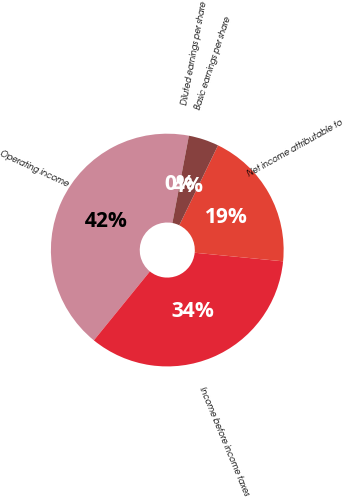<chart> <loc_0><loc_0><loc_500><loc_500><pie_chart><fcel>Operating income<fcel>Income before income taxes<fcel>Net income attributable to<fcel>Basic earnings per share<fcel>Diluted earnings per share<nl><fcel>42.11%<fcel>34.32%<fcel>19.36%<fcel>4.21%<fcel>0.0%<nl></chart> 